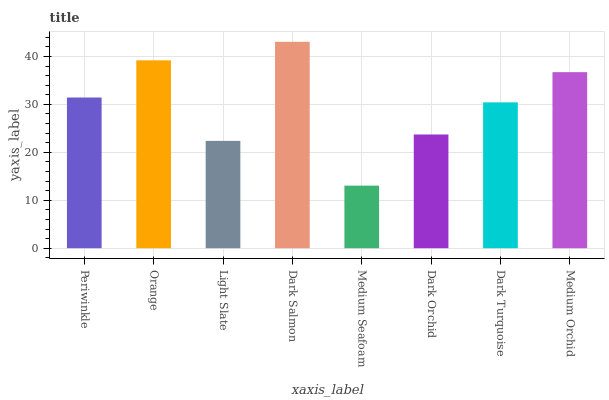Is Orange the minimum?
Answer yes or no. No. Is Orange the maximum?
Answer yes or no. No. Is Orange greater than Periwinkle?
Answer yes or no. Yes. Is Periwinkle less than Orange?
Answer yes or no. Yes. Is Periwinkle greater than Orange?
Answer yes or no. No. Is Orange less than Periwinkle?
Answer yes or no. No. Is Periwinkle the high median?
Answer yes or no. Yes. Is Dark Turquoise the low median?
Answer yes or no. Yes. Is Dark Orchid the high median?
Answer yes or no. No. Is Medium Orchid the low median?
Answer yes or no. No. 